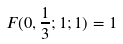<formula> <loc_0><loc_0><loc_500><loc_500>F ( 0 , \frac { 1 } { 3 } ; 1 ; 1 ) = 1</formula> 